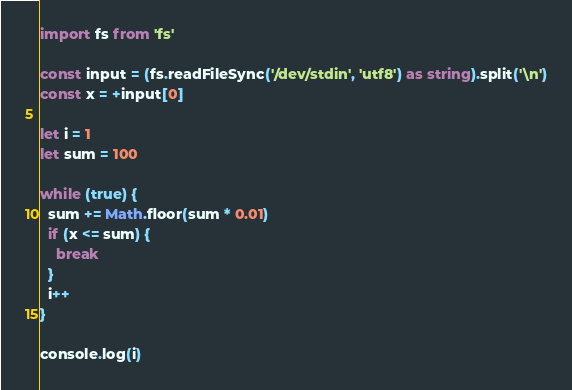Convert code to text. <code><loc_0><loc_0><loc_500><loc_500><_TypeScript_>import fs from 'fs'

const input = (fs.readFileSync('/dev/stdin', 'utf8') as string).split('\n')
const x = +input[0]

let i = 1
let sum = 100

while (true) {
  sum += Math.floor(sum * 0.01)
  if (x <= sum) {
    break
  }
  i++
}

console.log(i)
</code> 